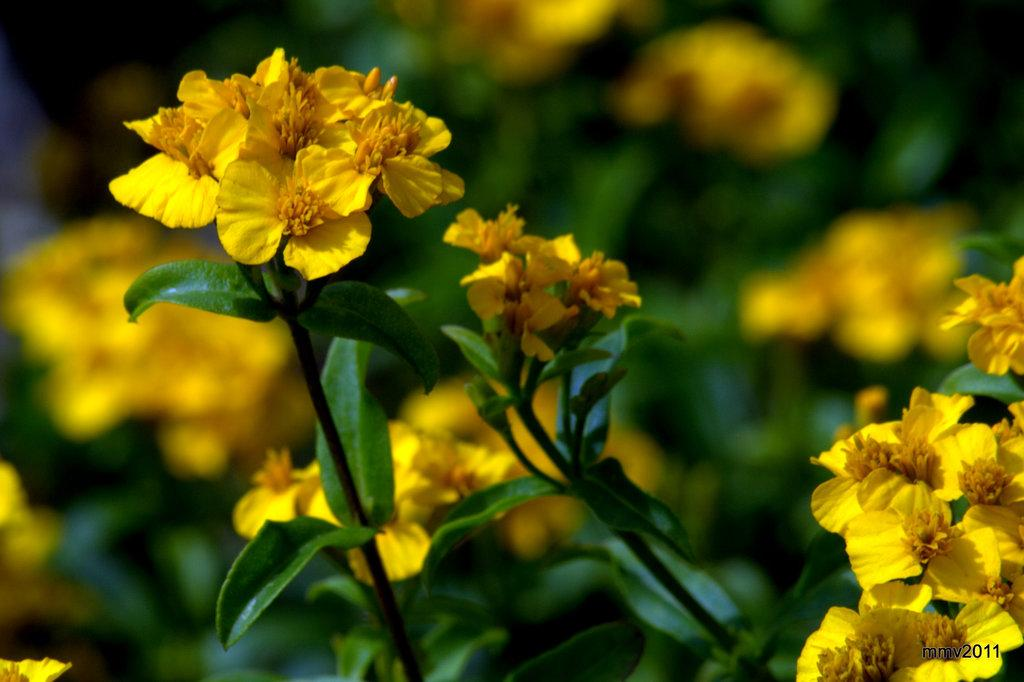What color are the flowers in the image? The flowers in the image are yellow. What color are the leaves in the image? The leaves in the image are green. How are the leaves connected to the flowers? The leaves are attached to stems. What can be observed about the background of the image? The background of the image is blurred. What type of jewel can be seen in the hands of the friends in the image? There are no friends or jewels present in the image; it features yellow flowers and green leaves with attached stems. 